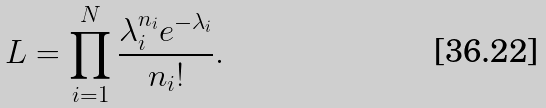<formula> <loc_0><loc_0><loc_500><loc_500>L = \prod _ { i = 1 } ^ { N } \frac { \lambda _ { i } ^ { n _ { i } } e ^ { - \lambda _ { i } } } { n _ { i } ! } .</formula> 